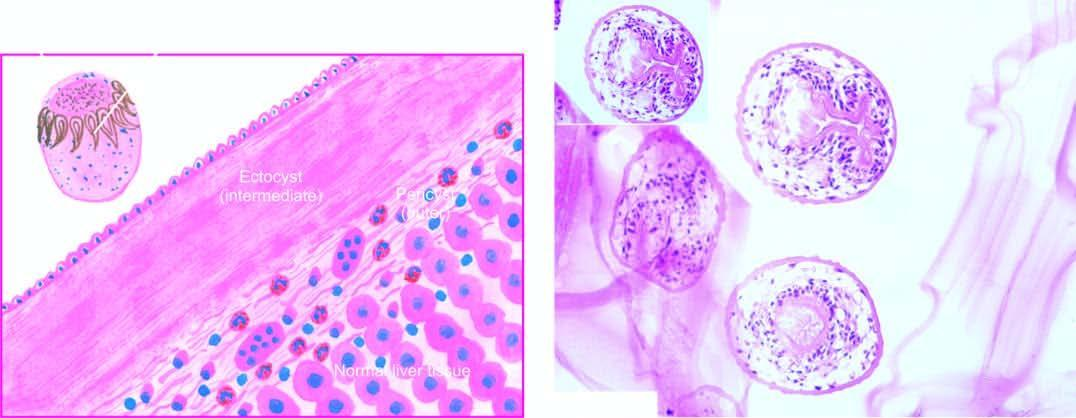what does microscopy show?
Answer the question using a single word or phrase. Three layers in the wall of hydatid cyst 